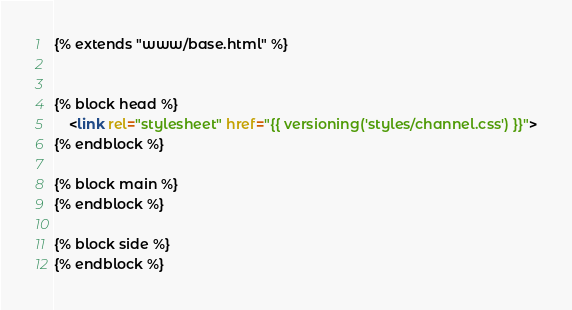Convert code to text. <code><loc_0><loc_0><loc_500><loc_500><_HTML_>{% extends "www/base.html" %}


{% block head %}
	<link rel="stylesheet" href="{{ versioning('styles/channel.css') }}">
{% endblock %}

{% block main %}
{% endblock %}

{% block side %}
{% endblock %}
</code> 